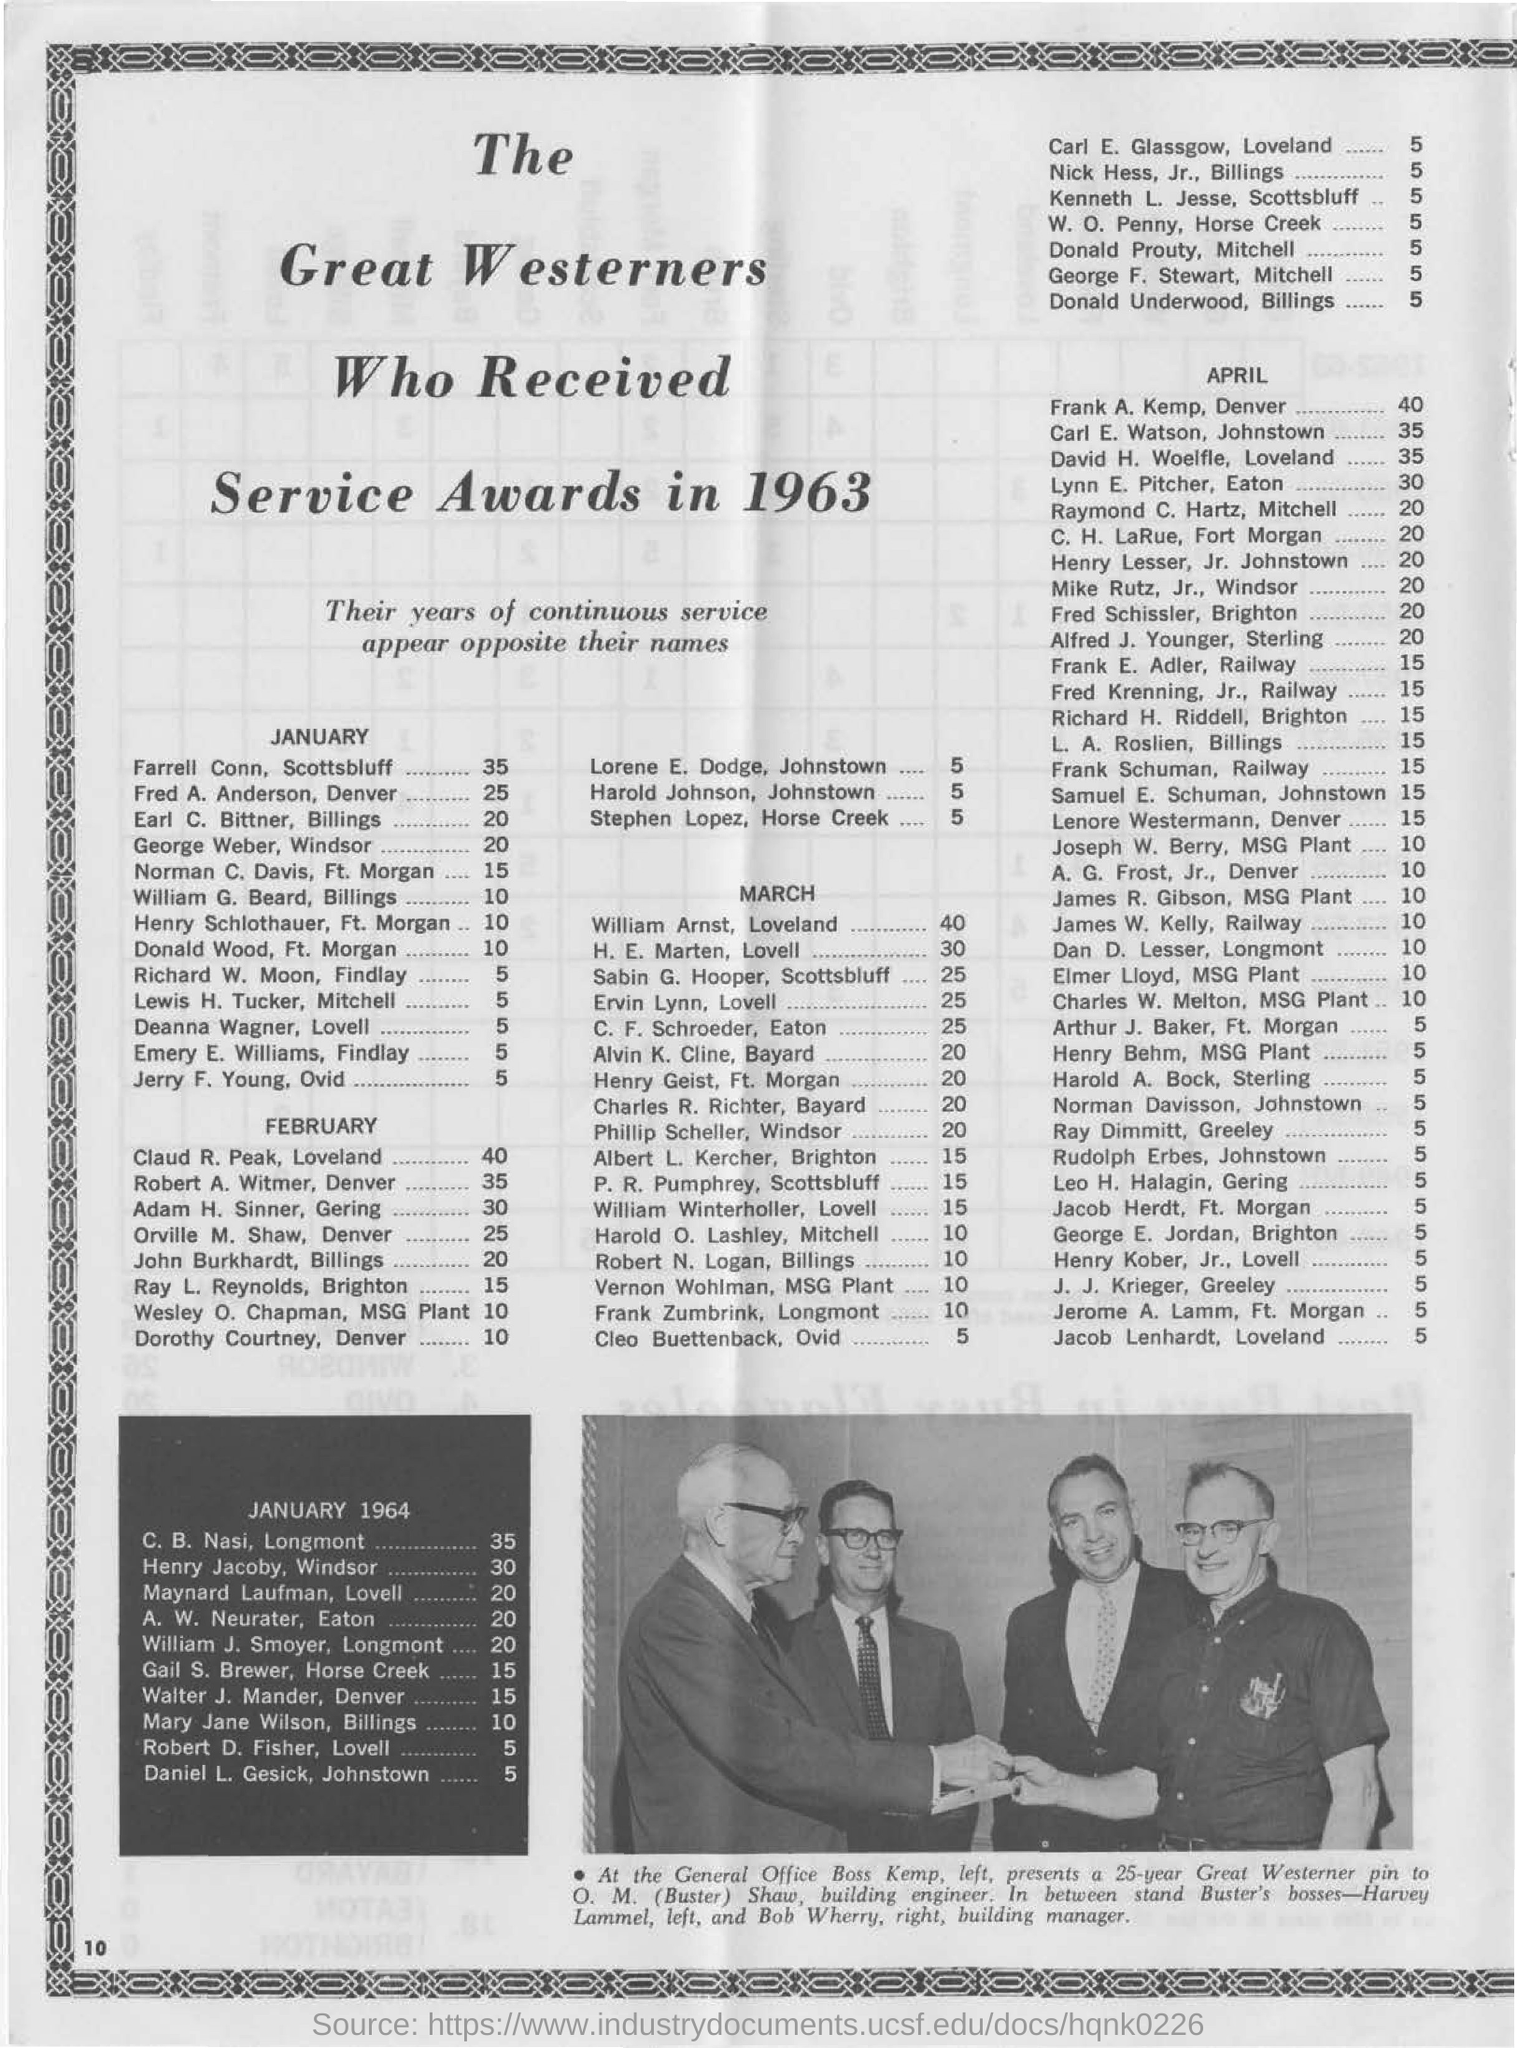Give some essential details in this illustration. In February, Claud R. Peak of Loveland will reach 40 years of continuous service. The service awards were given to the great westerners in the document in 1963. It is expected that Farrell Conn and Scott's Bluff will achieve 35 years of continuous service in January. Farrell Conn of Scottsbluff achieved 35 years of continuous service. 